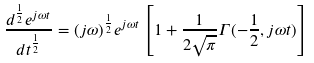<formula> <loc_0><loc_0><loc_500><loc_500>\frac { d ^ { \frac { 1 } { 2 } } e ^ { j \omega t } } { d t ^ { \frac { 1 } { 2 } } } = ( j \omega ) ^ { \frac { 1 } { 2 } } e ^ { j \omega t } \left [ 1 + \frac { 1 } { 2 \sqrt { \pi } } \Gamma ( - \frac { 1 } { 2 } , j \omega t ) \right ]</formula> 